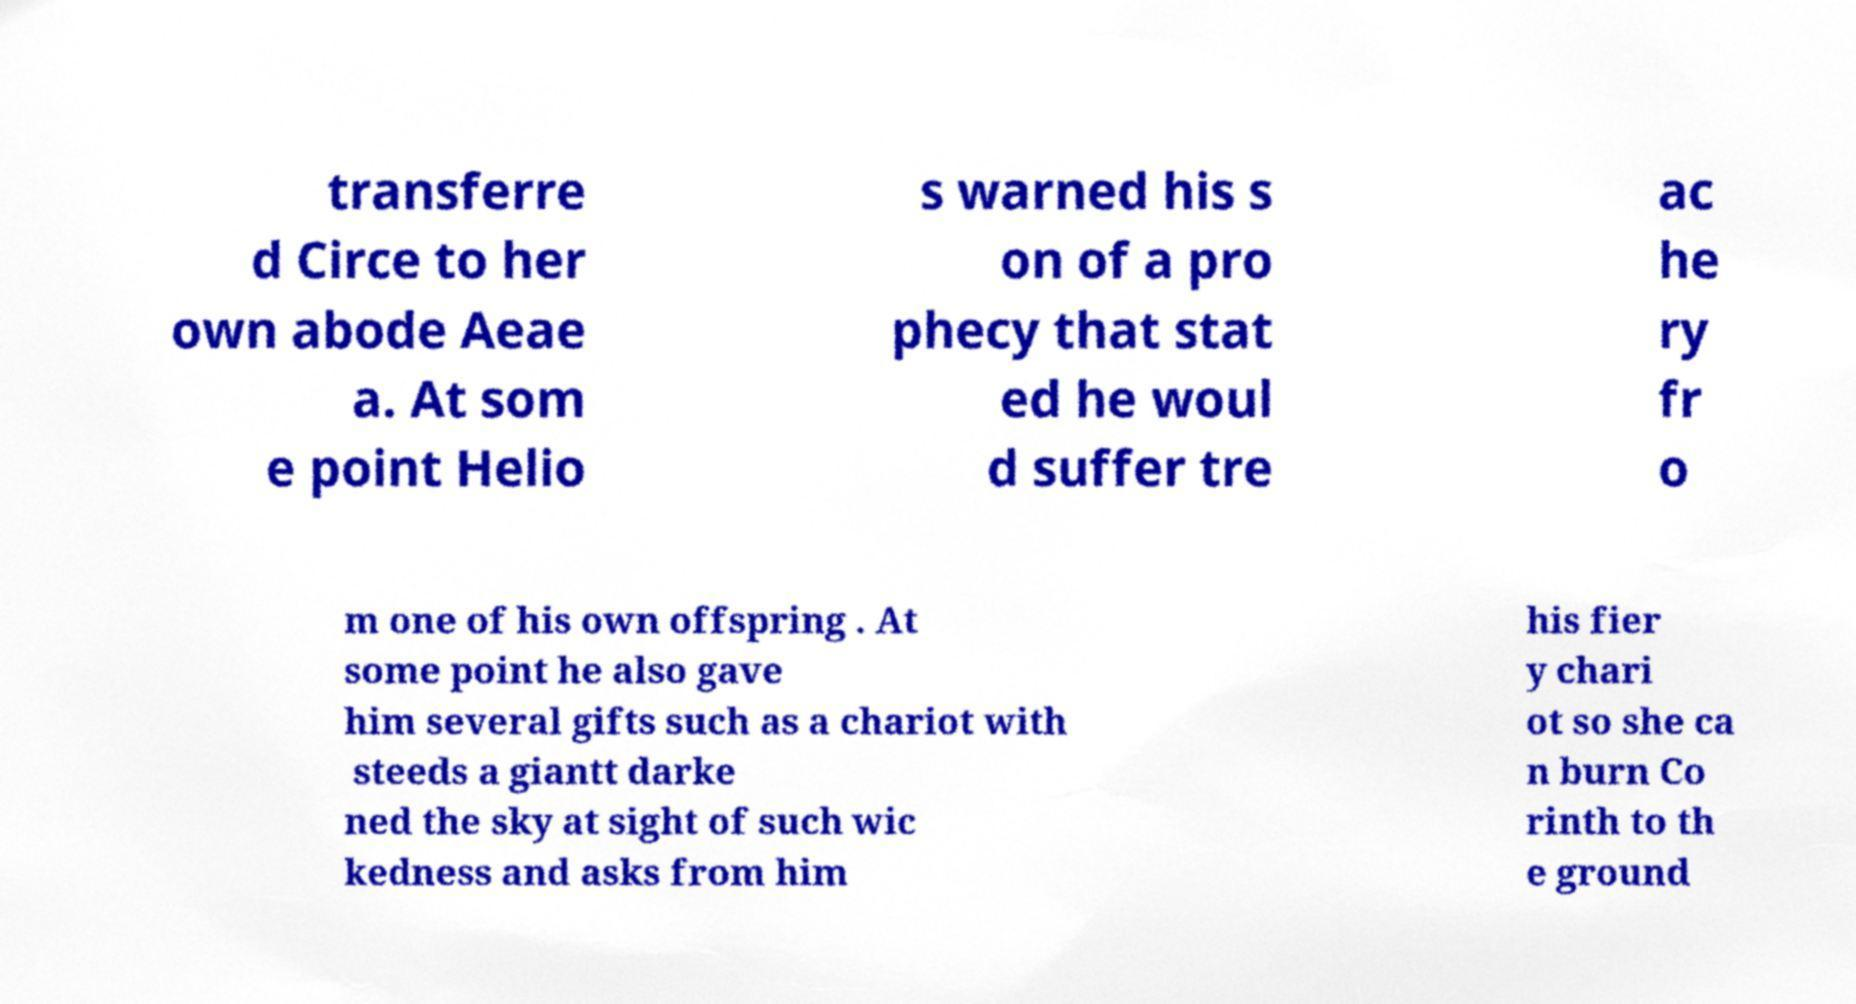Can you accurately transcribe the text from the provided image for me? transferre d Circe to her own abode Aeae a. At som e point Helio s warned his s on of a pro phecy that stat ed he woul d suffer tre ac he ry fr o m one of his own offspring . At some point he also gave him several gifts such as a chariot with steeds a giantt darke ned the sky at sight of such wic kedness and asks from him his fier y chari ot so she ca n burn Co rinth to th e ground 